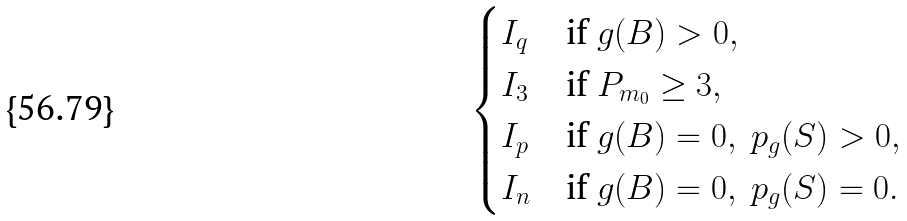<formula> <loc_0><loc_0><loc_500><loc_500>\begin{cases} I _ { q } & \text {if} \ g ( B ) > 0 , \\ I _ { 3 } & \text {if} \ P _ { m _ { 0 } } \geq 3 , \\ I _ { p } & \text {if} \ g ( B ) = 0 , \ p _ { g } ( S ) > 0 , \\ I _ { n } & \text {if} \ g ( B ) = 0 , \ p _ { g } ( S ) = 0 . \\ \end{cases}</formula> 